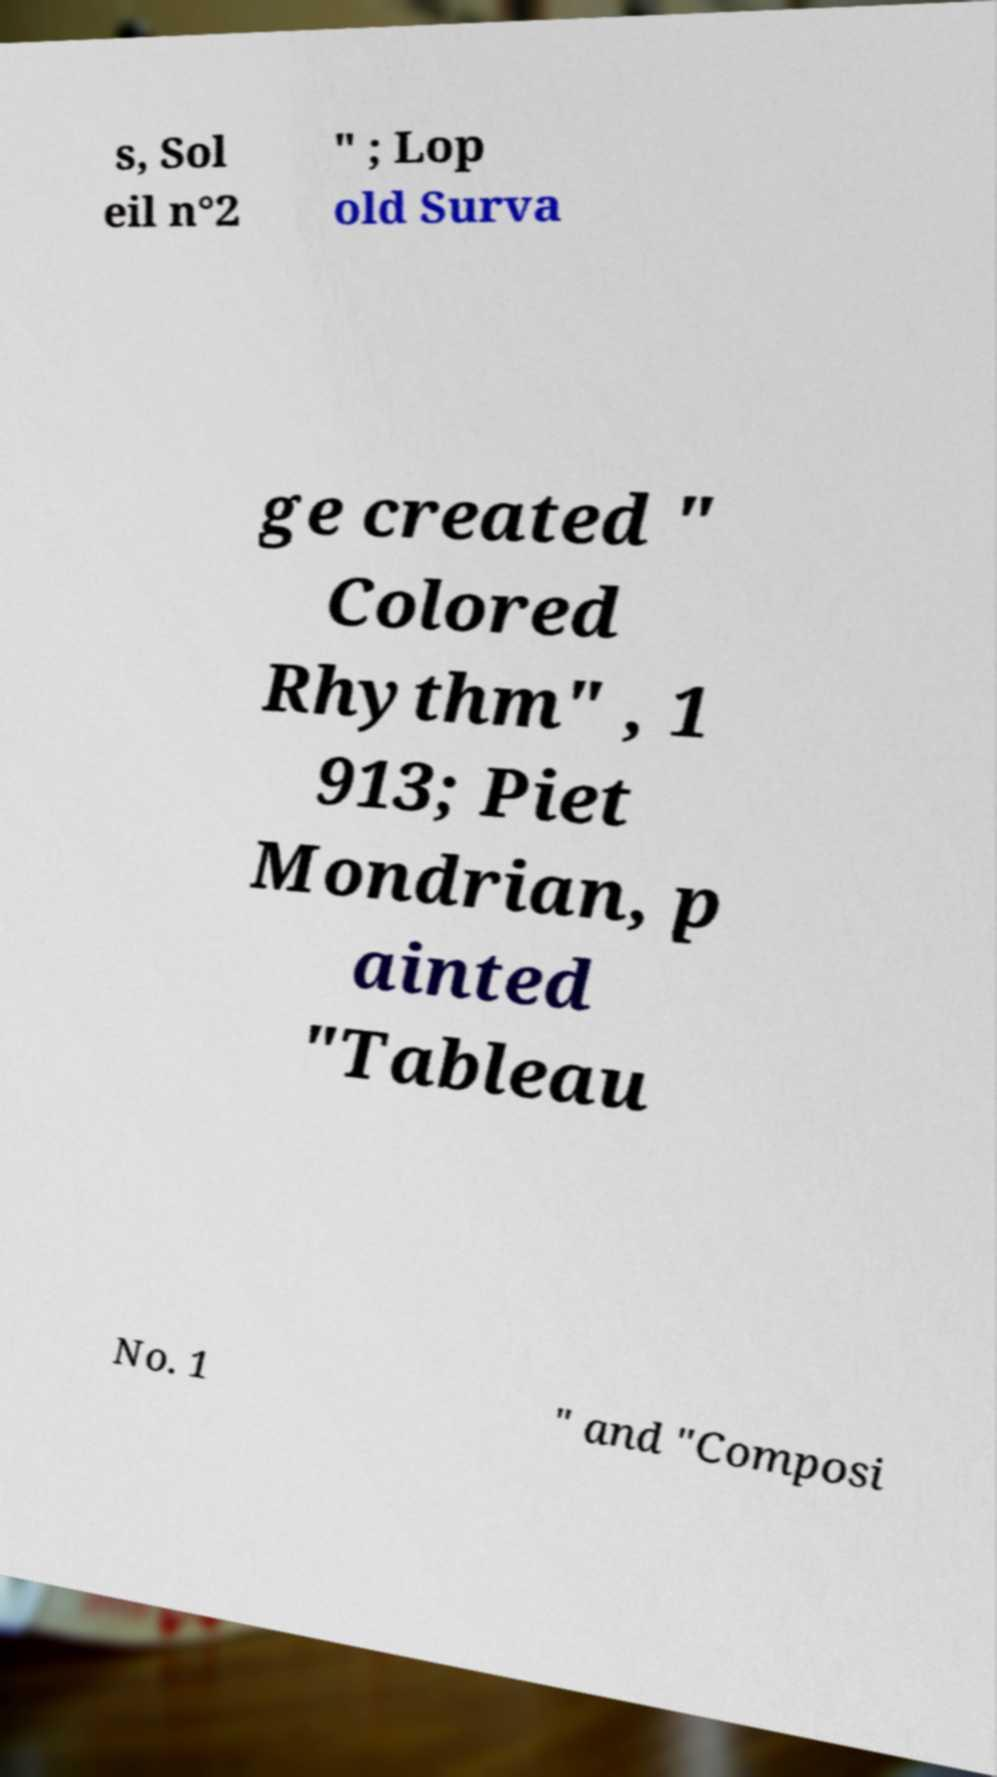Can you accurately transcribe the text from the provided image for me? s, Sol eil n°2 " ; Lop old Surva ge created " Colored Rhythm" , 1 913; Piet Mondrian, p ainted "Tableau No. 1 " and "Composi 